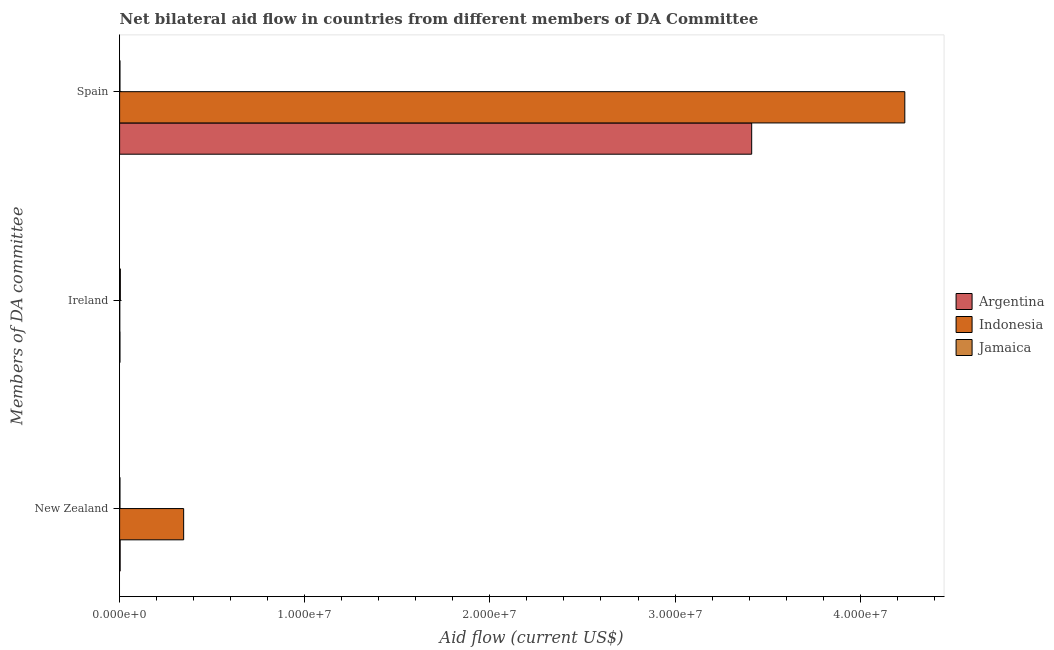How many different coloured bars are there?
Your response must be concise. 3. How many groups of bars are there?
Keep it short and to the point. 3. How many bars are there on the 1st tick from the top?
Keep it short and to the point. 3. What is the label of the 3rd group of bars from the top?
Offer a terse response. New Zealand. What is the amount of aid provided by new zealand in Argentina?
Offer a very short reply. 3.00e+04. Across all countries, what is the maximum amount of aid provided by ireland?
Your answer should be very brief. 4.00e+04. Across all countries, what is the minimum amount of aid provided by ireland?
Give a very brief answer. 10000. In which country was the amount of aid provided by spain maximum?
Keep it short and to the point. Indonesia. In which country was the amount of aid provided by spain minimum?
Keep it short and to the point. Jamaica. What is the total amount of aid provided by ireland in the graph?
Keep it short and to the point. 7.00e+04. What is the difference between the amount of aid provided by new zealand in Jamaica and that in Indonesia?
Ensure brevity in your answer.  -3.44e+06. What is the difference between the amount of aid provided by new zealand in Argentina and the amount of aid provided by ireland in Indonesia?
Make the answer very short. 2.00e+04. What is the average amount of aid provided by spain per country?
Make the answer very short. 2.55e+07. What is the difference between the amount of aid provided by new zealand and amount of aid provided by ireland in Argentina?
Your response must be concise. 10000. What is the ratio of the amount of aid provided by spain in Indonesia to that in Argentina?
Your answer should be compact. 1.24. Is the difference between the amount of aid provided by spain in Jamaica and Argentina greater than the difference between the amount of aid provided by new zealand in Jamaica and Argentina?
Your response must be concise. No. What is the difference between the highest and the second highest amount of aid provided by spain?
Provide a succinct answer. 8.27e+06. What is the difference between the highest and the lowest amount of aid provided by ireland?
Offer a terse response. 3.00e+04. In how many countries, is the amount of aid provided by ireland greater than the average amount of aid provided by ireland taken over all countries?
Your response must be concise. 1. Is the sum of the amount of aid provided by spain in Argentina and Jamaica greater than the maximum amount of aid provided by ireland across all countries?
Your response must be concise. Yes. What does the 1st bar from the top in Spain represents?
Offer a very short reply. Jamaica. What does the 3rd bar from the bottom in New Zealand represents?
Offer a very short reply. Jamaica. Are all the bars in the graph horizontal?
Make the answer very short. Yes. What is the difference between two consecutive major ticks on the X-axis?
Provide a short and direct response. 1.00e+07. Are the values on the major ticks of X-axis written in scientific E-notation?
Offer a terse response. Yes. Where does the legend appear in the graph?
Your answer should be very brief. Center right. How are the legend labels stacked?
Offer a very short reply. Vertical. What is the title of the graph?
Your answer should be compact. Net bilateral aid flow in countries from different members of DA Committee. Does "Iraq" appear as one of the legend labels in the graph?
Your response must be concise. No. What is the label or title of the X-axis?
Offer a terse response. Aid flow (current US$). What is the label or title of the Y-axis?
Ensure brevity in your answer.  Members of DA committee. What is the Aid flow (current US$) of Argentina in New Zealand?
Keep it short and to the point. 3.00e+04. What is the Aid flow (current US$) in Indonesia in New Zealand?
Your answer should be compact. 3.46e+06. What is the Aid flow (current US$) in Jamaica in New Zealand?
Offer a terse response. 2.00e+04. What is the Aid flow (current US$) of Jamaica in Ireland?
Offer a very short reply. 4.00e+04. What is the Aid flow (current US$) of Argentina in Spain?
Provide a succinct answer. 3.41e+07. What is the Aid flow (current US$) in Indonesia in Spain?
Offer a very short reply. 4.24e+07. What is the Aid flow (current US$) in Jamaica in Spain?
Give a very brief answer. 2.00e+04. Across all Members of DA committee, what is the maximum Aid flow (current US$) in Argentina?
Ensure brevity in your answer.  3.41e+07. Across all Members of DA committee, what is the maximum Aid flow (current US$) in Indonesia?
Keep it short and to the point. 4.24e+07. Across all Members of DA committee, what is the minimum Aid flow (current US$) of Argentina?
Make the answer very short. 2.00e+04. Across all Members of DA committee, what is the minimum Aid flow (current US$) in Indonesia?
Ensure brevity in your answer.  10000. What is the total Aid flow (current US$) of Argentina in the graph?
Offer a very short reply. 3.42e+07. What is the total Aid flow (current US$) of Indonesia in the graph?
Give a very brief answer. 4.59e+07. What is the difference between the Aid flow (current US$) of Indonesia in New Zealand and that in Ireland?
Give a very brief answer. 3.45e+06. What is the difference between the Aid flow (current US$) of Jamaica in New Zealand and that in Ireland?
Offer a terse response. -2.00e+04. What is the difference between the Aid flow (current US$) of Argentina in New Zealand and that in Spain?
Provide a short and direct response. -3.41e+07. What is the difference between the Aid flow (current US$) in Indonesia in New Zealand and that in Spain?
Your answer should be very brief. -3.90e+07. What is the difference between the Aid flow (current US$) of Jamaica in New Zealand and that in Spain?
Ensure brevity in your answer.  0. What is the difference between the Aid flow (current US$) of Argentina in Ireland and that in Spain?
Your response must be concise. -3.41e+07. What is the difference between the Aid flow (current US$) of Indonesia in Ireland and that in Spain?
Keep it short and to the point. -4.24e+07. What is the difference between the Aid flow (current US$) of Jamaica in Ireland and that in Spain?
Your response must be concise. 2.00e+04. What is the difference between the Aid flow (current US$) of Argentina in New Zealand and the Aid flow (current US$) of Jamaica in Ireland?
Offer a terse response. -10000. What is the difference between the Aid flow (current US$) in Indonesia in New Zealand and the Aid flow (current US$) in Jamaica in Ireland?
Make the answer very short. 3.42e+06. What is the difference between the Aid flow (current US$) in Argentina in New Zealand and the Aid flow (current US$) in Indonesia in Spain?
Your answer should be compact. -4.24e+07. What is the difference between the Aid flow (current US$) of Argentina in New Zealand and the Aid flow (current US$) of Jamaica in Spain?
Your answer should be very brief. 10000. What is the difference between the Aid flow (current US$) of Indonesia in New Zealand and the Aid flow (current US$) of Jamaica in Spain?
Provide a short and direct response. 3.44e+06. What is the difference between the Aid flow (current US$) in Argentina in Ireland and the Aid flow (current US$) in Indonesia in Spain?
Make the answer very short. -4.24e+07. What is the difference between the Aid flow (current US$) in Argentina in Ireland and the Aid flow (current US$) in Jamaica in Spain?
Your answer should be very brief. 0. What is the difference between the Aid flow (current US$) of Indonesia in Ireland and the Aid flow (current US$) of Jamaica in Spain?
Give a very brief answer. -10000. What is the average Aid flow (current US$) of Argentina per Members of DA committee?
Offer a terse response. 1.14e+07. What is the average Aid flow (current US$) in Indonesia per Members of DA committee?
Make the answer very short. 1.53e+07. What is the average Aid flow (current US$) in Jamaica per Members of DA committee?
Your response must be concise. 2.67e+04. What is the difference between the Aid flow (current US$) of Argentina and Aid flow (current US$) of Indonesia in New Zealand?
Keep it short and to the point. -3.43e+06. What is the difference between the Aid flow (current US$) in Indonesia and Aid flow (current US$) in Jamaica in New Zealand?
Your answer should be compact. 3.44e+06. What is the difference between the Aid flow (current US$) of Argentina and Aid flow (current US$) of Jamaica in Ireland?
Make the answer very short. -2.00e+04. What is the difference between the Aid flow (current US$) of Indonesia and Aid flow (current US$) of Jamaica in Ireland?
Offer a terse response. -3.00e+04. What is the difference between the Aid flow (current US$) in Argentina and Aid flow (current US$) in Indonesia in Spain?
Ensure brevity in your answer.  -8.27e+06. What is the difference between the Aid flow (current US$) of Argentina and Aid flow (current US$) of Jamaica in Spain?
Offer a terse response. 3.41e+07. What is the difference between the Aid flow (current US$) of Indonesia and Aid flow (current US$) of Jamaica in Spain?
Provide a short and direct response. 4.24e+07. What is the ratio of the Aid flow (current US$) in Argentina in New Zealand to that in Ireland?
Your answer should be very brief. 1.5. What is the ratio of the Aid flow (current US$) in Indonesia in New Zealand to that in Ireland?
Make the answer very short. 346. What is the ratio of the Aid flow (current US$) in Argentina in New Zealand to that in Spain?
Give a very brief answer. 0. What is the ratio of the Aid flow (current US$) in Indonesia in New Zealand to that in Spain?
Your answer should be very brief. 0.08. What is the ratio of the Aid flow (current US$) of Argentina in Ireland to that in Spain?
Offer a very short reply. 0. What is the ratio of the Aid flow (current US$) in Jamaica in Ireland to that in Spain?
Keep it short and to the point. 2. What is the difference between the highest and the second highest Aid flow (current US$) of Argentina?
Give a very brief answer. 3.41e+07. What is the difference between the highest and the second highest Aid flow (current US$) in Indonesia?
Provide a short and direct response. 3.90e+07. What is the difference between the highest and the lowest Aid flow (current US$) in Argentina?
Your answer should be very brief. 3.41e+07. What is the difference between the highest and the lowest Aid flow (current US$) of Indonesia?
Keep it short and to the point. 4.24e+07. 